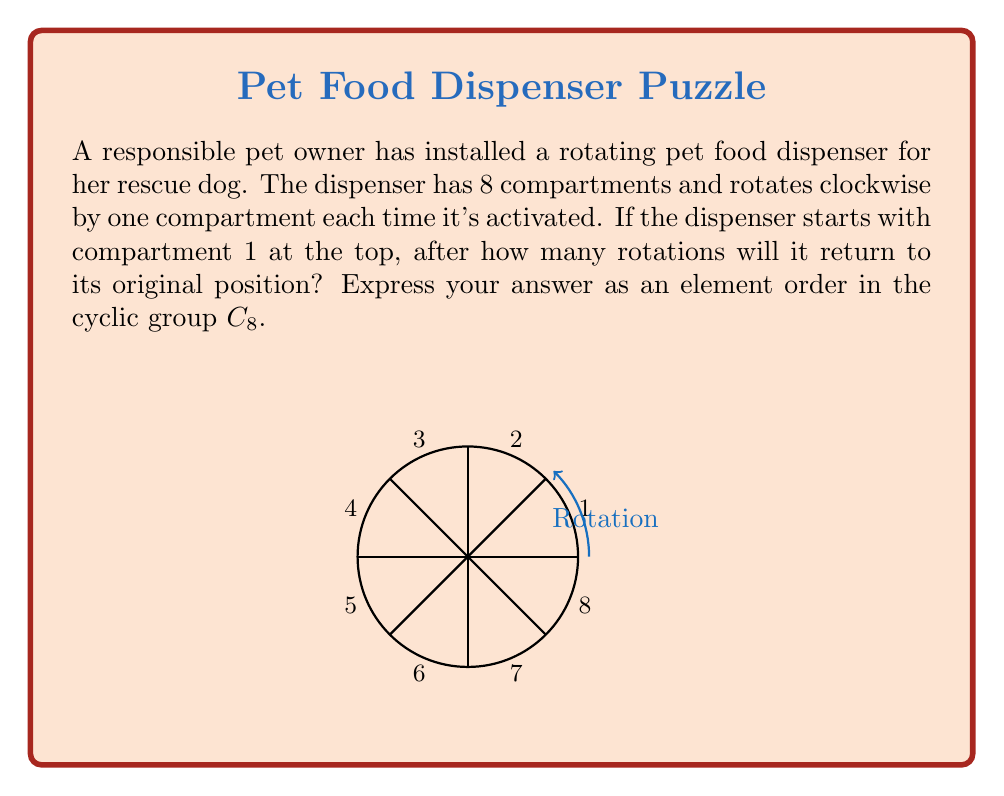Could you help me with this problem? Let's approach this step-by-step:

1) The rotating pet food dispenser can be modeled as a cyclic group $C_8$ of order 8, where each element represents a rotation by one compartment.

2) Let $g$ be the generator of this group, representing a single rotation. We want to find the smallest positive integer $n$ such that $g^n = e$, where $e$ is the identity element (the original position).

3) In $C_8$, we know that $g^8 = e$ because after 8 rotations, we return to the starting position.

4) However, we need to check if there's a smaller $n$ that satisfies this condition:

   $g^1 \neq e$
   $g^2 \neq e$
   $g^3 \neq e$
   $g^4 \neq e$
   $g^5 \neq e$
   $g^6 \neq e$
   $g^7 \neq e$
   $g^8 = e$

5) We see that 8 is the smallest positive integer $n$ such that $g^n = e$.

6) In group theory, this means that the order of the element $g$ is 8.

Therefore, the dispenser will return to its original position after 8 rotations, and the order of the generating element in $C_8$ is 8.
Answer: $|g| = 8$ in $C_8$ 